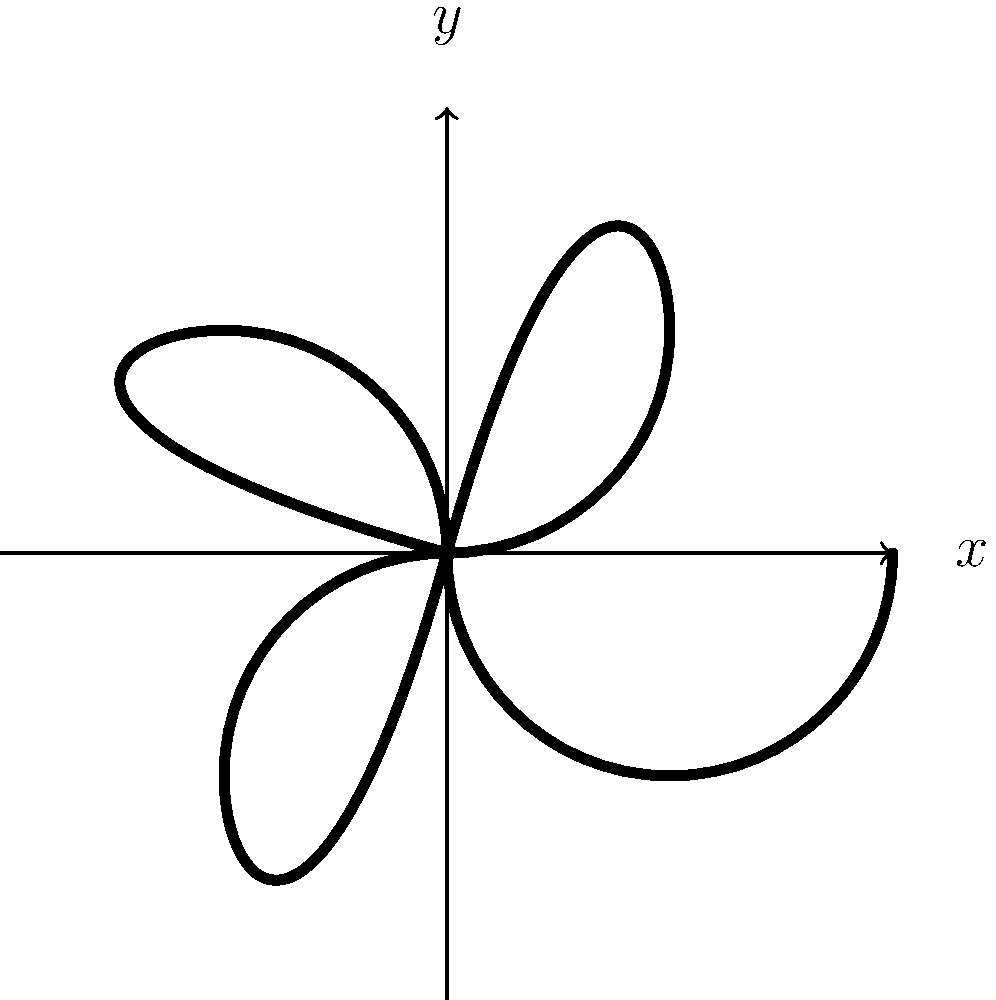In traditional Maori tattoo patterns, the koru spiral is a common motif. The image shows a simplified representation of a koru-based pattern. What is the order of the rotational symmetry group for this pattern? To determine the order of the rotational symmetry group for this pattern, we need to follow these steps:

1. Observe the pattern carefully. It consists of four identical koru spirals arranged around a central point.

2. Identify the rotations that leave the pattern unchanged:
   - 0° (identity rotation)
   - 90° clockwise
   - 180° (half turn)
   - 270° clockwise (or 90° counterclockwise)

3. Count the number of distinct rotations that preserve the pattern. In this case, there are 4 rotations (including the identity rotation).

4. The order of the rotational symmetry group is equal to the number of distinct rotations that preserve the pattern.

Therefore, the order of the rotational symmetry group for this koru-based pattern is 4. In group theory notation, this symmetry group is isomorphic to the cyclic group $C_4$ or $\mathbb{Z}_4$.
Answer: 4 